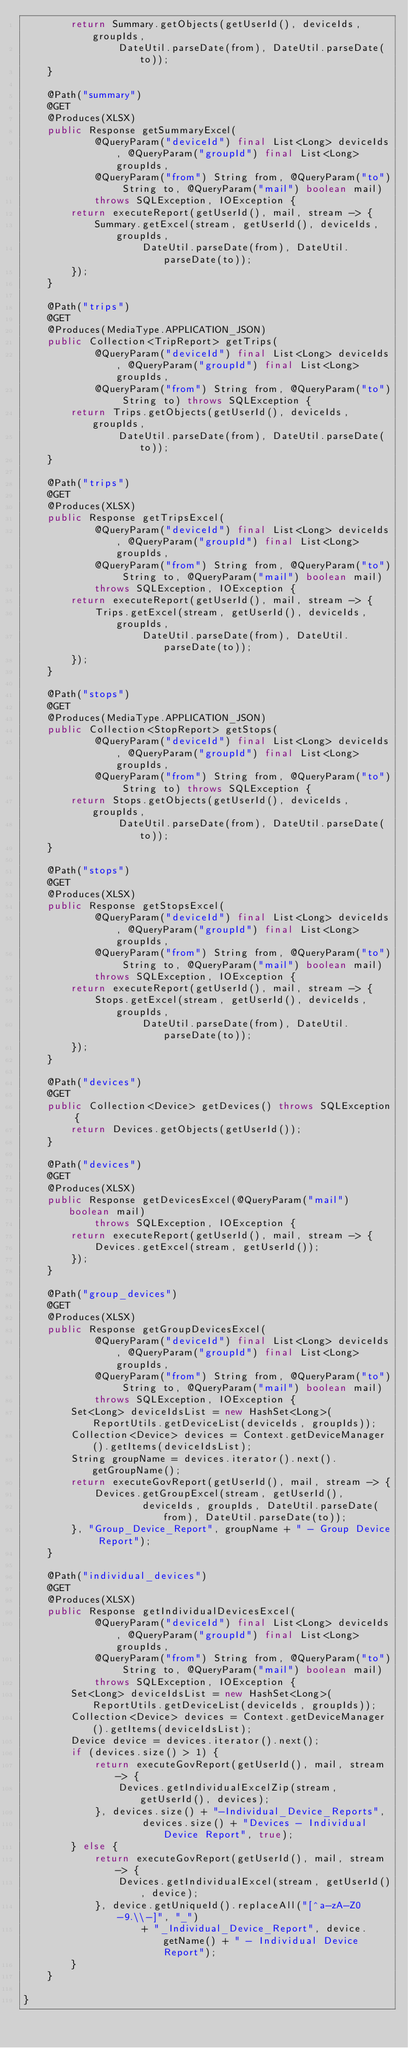<code> <loc_0><loc_0><loc_500><loc_500><_Java_>        return Summary.getObjects(getUserId(), deviceIds, groupIds,
                DateUtil.parseDate(from), DateUtil.parseDate(to));
    }

    @Path("summary")
    @GET
    @Produces(XLSX)
    public Response getSummaryExcel(
            @QueryParam("deviceId") final List<Long> deviceIds, @QueryParam("groupId") final List<Long> groupIds,
            @QueryParam("from") String from, @QueryParam("to") String to, @QueryParam("mail") boolean mail)
            throws SQLException, IOException {
        return executeReport(getUserId(), mail, stream -> {
            Summary.getExcel(stream, getUserId(), deviceIds, groupIds,
                    DateUtil.parseDate(from), DateUtil.parseDate(to));
        });
    }

    @Path("trips")
    @GET
    @Produces(MediaType.APPLICATION_JSON)
    public Collection<TripReport> getTrips(
            @QueryParam("deviceId") final List<Long> deviceIds, @QueryParam("groupId") final List<Long> groupIds,
            @QueryParam("from") String from, @QueryParam("to") String to) throws SQLException {
        return Trips.getObjects(getUserId(), deviceIds, groupIds,
                DateUtil.parseDate(from), DateUtil.parseDate(to));
    }

    @Path("trips")
    @GET
    @Produces(XLSX)
    public Response getTripsExcel(
            @QueryParam("deviceId") final List<Long> deviceIds, @QueryParam("groupId") final List<Long> groupIds,
            @QueryParam("from") String from, @QueryParam("to") String to, @QueryParam("mail") boolean mail)
            throws SQLException, IOException {
        return executeReport(getUserId(), mail, stream -> {
            Trips.getExcel(stream, getUserId(), deviceIds, groupIds,
                    DateUtil.parseDate(from), DateUtil.parseDate(to));
        });
    }

    @Path("stops")
    @GET
    @Produces(MediaType.APPLICATION_JSON)
    public Collection<StopReport> getStops(
            @QueryParam("deviceId") final List<Long> deviceIds, @QueryParam("groupId") final List<Long> groupIds,
            @QueryParam("from") String from, @QueryParam("to") String to) throws SQLException {
        return Stops.getObjects(getUserId(), deviceIds, groupIds,
                DateUtil.parseDate(from), DateUtil.parseDate(to));
    }

    @Path("stops")
    @GET
    @Produces(XLSX)
    public Response getStopsExcel(
            @QueryParam("deviceId") final List<Long> deviceIds, @QueryParam("groupId") final List<Long> groupIds,
            @QueryParam("from") String from, @QueryParam("to") String to, @QueryParam("mail") boolean mail)
            throws SQLException, IOException {
        return executeReport(getUserId(), mail, stream -> {
            Stops.getExcel(stream, getUserId(), deviceIds, groupIds,
                    DateUtil.parseDate(from), DateUtil.parseDate(to));
        });
    }

    @Path("devices")
    @GET
    public Collection<Device> getDevices() throws SQLException {
        return Devices.getObjects(getUserId());
    }

    @Path("devices")
    @GET
    @Produces(XLSX)
    public Response getDevicesExcel(@QueryParam("mail") boolean mail)
            throws SQLException, IOException {
        return executeReport(getUserId(), mail, stream -> {
            Devices.getExcel(stream, getUserId());
        });
    }

    @Path("group_devices")
    @GET
    @Produces(XLSX)
    public Response getGroupDevicesExcel(
            @QueryParam("deviceId") final List<Long> deviceIds, @QueryParam("groupId") final List<Long> groupIds,
            @QueryParam("from") String from, @QueryParam("to") String to, @QueryParam("mail") boolean mail)
            throws SQLException, IOException {
        Set<Long> deviceIdsList = new HashSet<Long>(ReportUtils.getDeviceList(deviceIds, groupIds));
        Collection<Device> devices = Context.getDeviceManager().getItems(deviceIdsList);
        String groupName = devices.iterator().next().getGroupName();
        return executeGovReport(getUserId(), mail, stream -> {
            Devices.getGroupExcel(stream, getUserId(),
                    deviceIds, groupIds, DateUtil.parseDate(from), DateUtil.parseDate(to));
        }, "Group_Device_Report", groupName + " - Group Device Report");
    }

    @Path("individual_devices")
    @GET
    @Produces(XLSX)
    public Response getIndividualDevicesExcel(
            @QueryParam("deviceId") final List<Long> deviceIds, @QueryParam("groupId") final List<Long> groupIds,
            @QueryParam("from") String from, @QueryParam("to") String to, @QueryParam("mail") boolean mail)
            throws SQLException, IOException {
        Set<Long> deviceIdsList = new HashSet<Long>(ReportUtils.getDeviceList(deviceIds, groupIds));
        Collection<Device> devices = Context.getDeviceManager().getItems(deviceIdsList);
        Device device = devices.iterator().next();
        if (devices.size() > 1) {
            return executeGovReport(getUserId(), mail, stream -> {
                Devices.getIndividualExcelZip(stream, getUserId(), devices);
            }, devices.size() + "-Individual_Device_Reports",
                    devices.size() + "Devices - Individual Device Report", true);
        } else {
            return executeGovReport(getUserId(), mail, stream -> {
                Devices.getIndividualExcel(stream, getUserId(), device);
            }, device.getUniqueId().replaceAll("[^a-zA-Z0-9.\\-]", "_")
                    + "_Individual_Device_Report", device.getName() + " - Individual Device Report");
        }
    }

}
</code> 